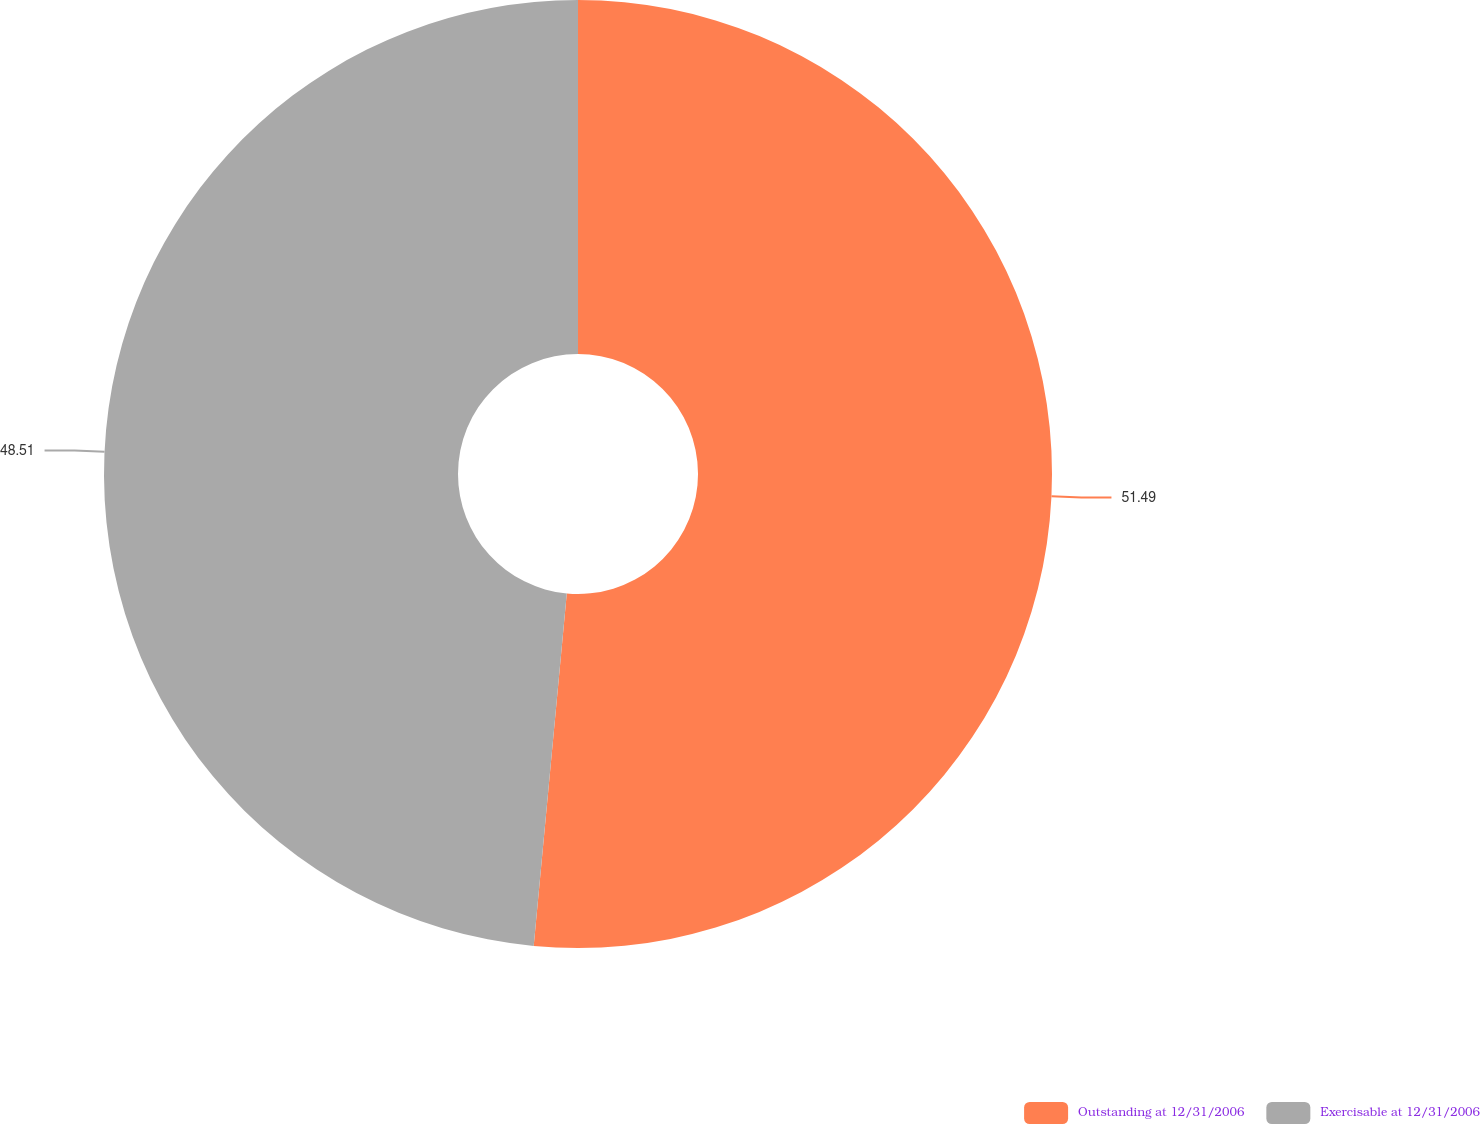Convert chart. <chart><loc_0><loc_0><loc_500><loc_500><pie_chart><fcel>Outstanding at 12/31/2006<fcel>Exercisable at 12/31/2006<nl><fcel>51.49%<fcel>48.51%<nl></chart> 